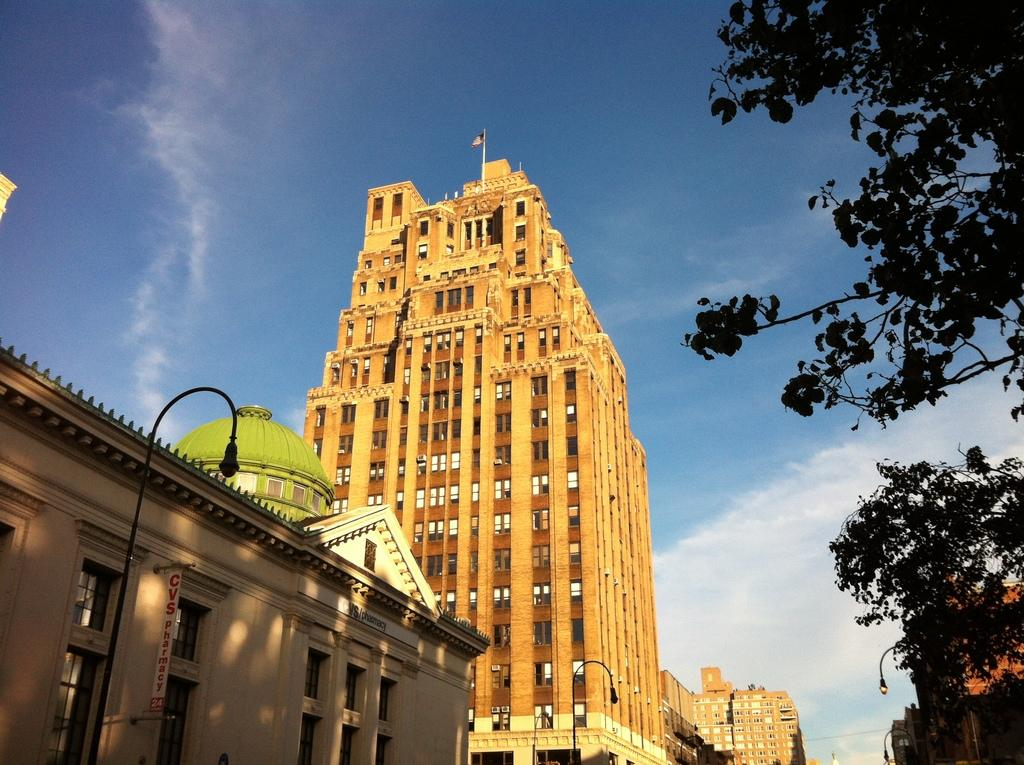What type of structures are visible in the image? There are buildings in the image. Where is the tree located in the image? The tree is on the right side of the image. What color is the sky in the background of the image? The background of the image includes a blue sky. How many cherries are hanging from the tree in the image? There are no cherries present in the image; it features a tree without any fruit. What type of marble is visible on the ground in the image? There is no marble visible in the image; the ground is not mentioned in the provided facts. 